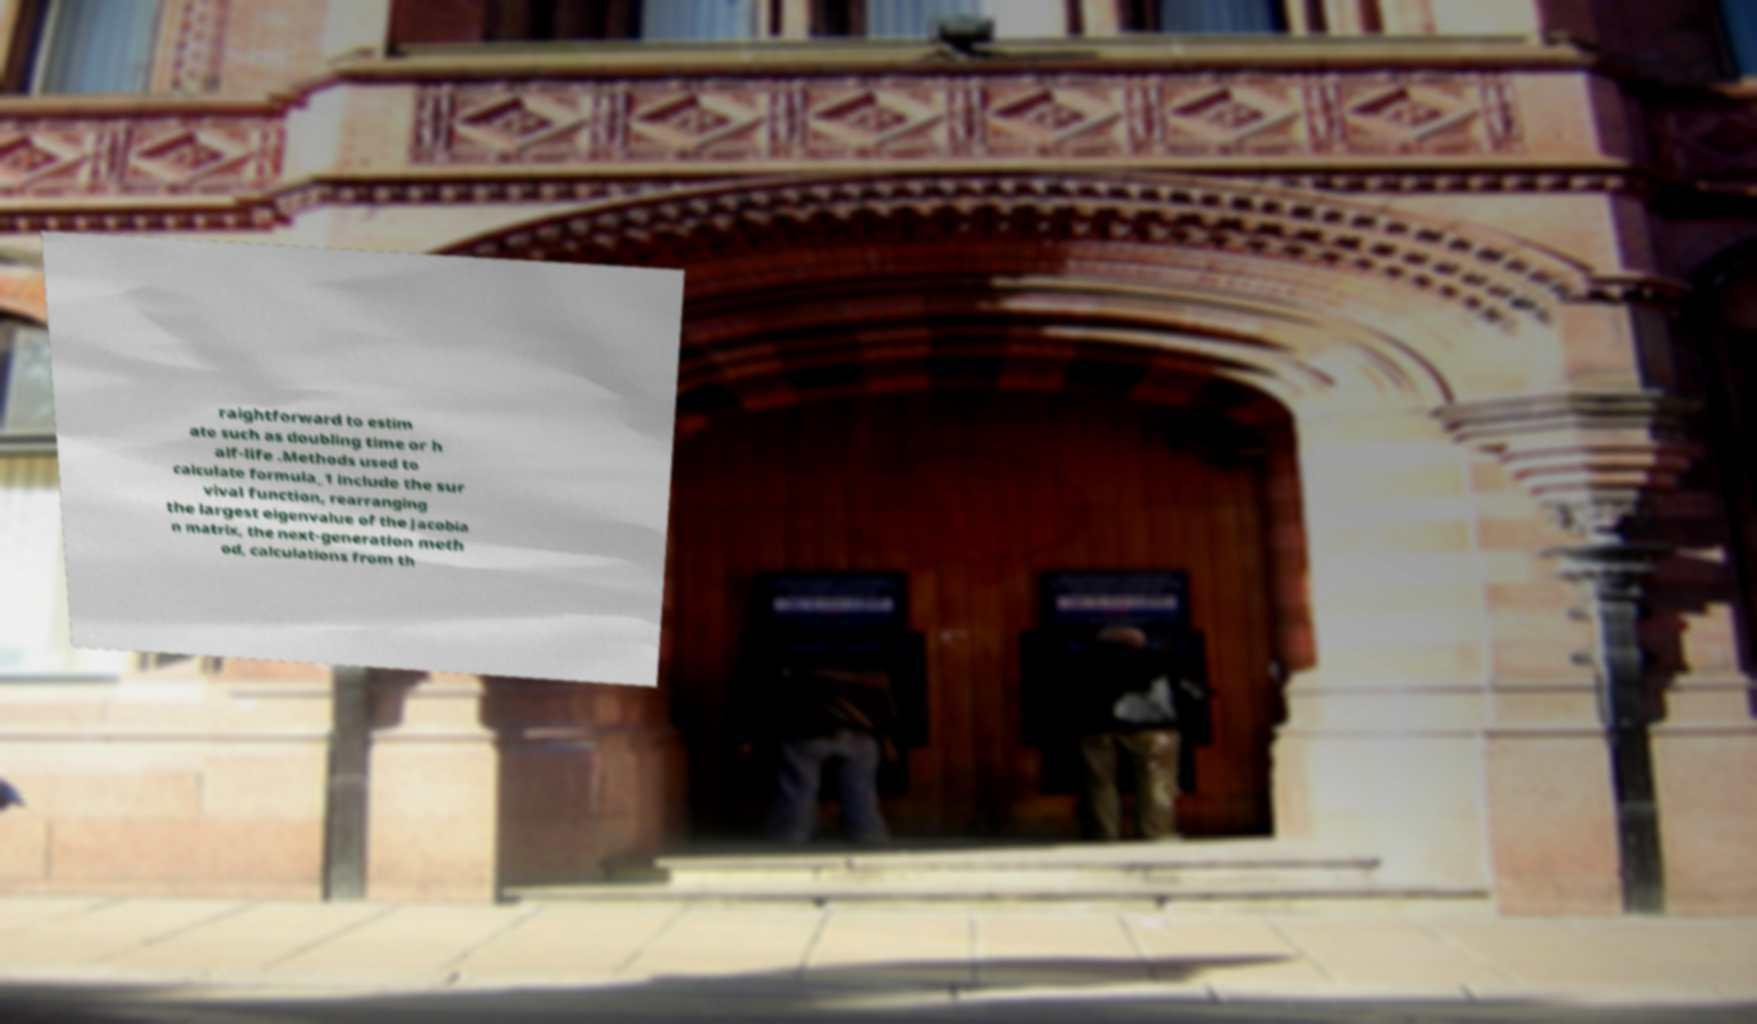Please identify and transcribe the text found in this image. raightforward to estim ate such as doubling time or h alf-life .Methods used to calculate formula_1 include the sur vival function, rearranging the largest eigenvalue of the Jacobia n matrix, the next-generation meth od, calculations from th 